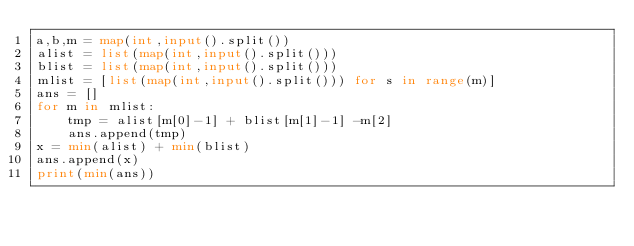<code> <loc_0><loc_0><loc_500><loc_500><_Python_>a,b,m = map(int,input().split())
alist = list(map(int,input().split()))
blist = list(map(int,input().split()))
mlist = [list(map(int,input().split())) for s in range(m)]
ans = []
for m in mlist:
	tmp = alist[m[0]-1] + blist[m[1]-1] -m[2]
	ans.append(tmp)
x = min(alist) + min(blist)
ans.append(x)
print(min(ans))</code> 